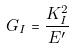<formula> <loc_0><loc_0><loc_500><loc_500>G _ { I } = \frac { K _ { I } ^ { 2 } } { E ^ { \prime } }</formula> 